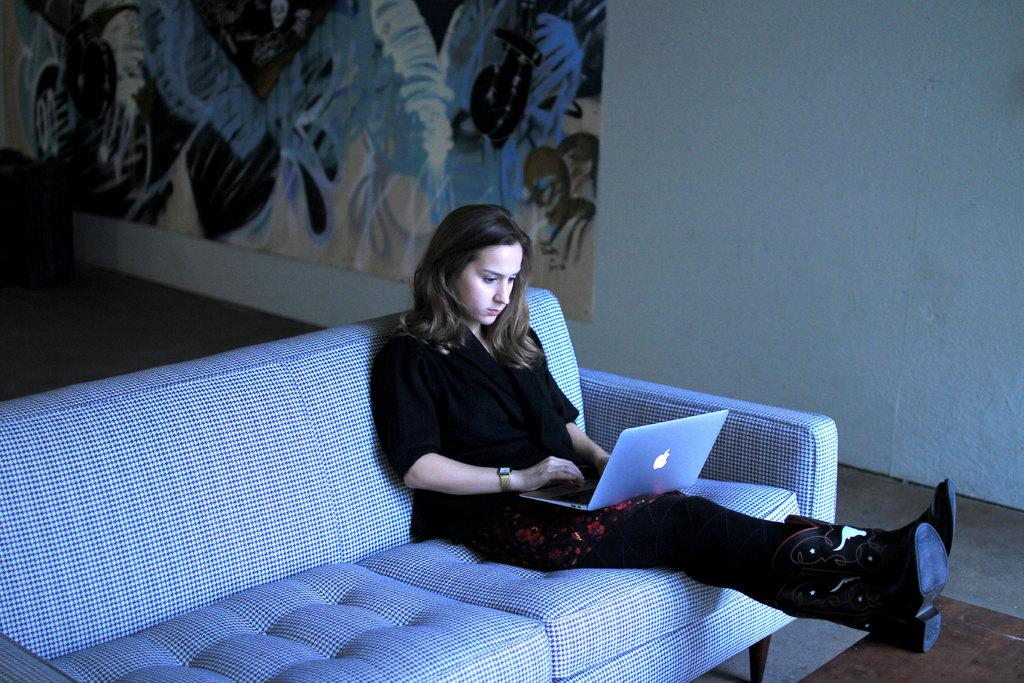Who is the main subject in the image? There is a girl in the image. What is the girl doing in the image? The girl is sitting on a sofa. What object is the girl holding in the image? The girl is holding a laptop. What can be seen on the wall behind the girl? There is a big painting on the wall behind her. What type of train is passing by in the image? There is no train present in the image; it features a girl sitting on a sofa with a laptop and a big painting on the wall behind her. What is the girl's partner doing in the image? There is no partner present in the image; it only shows the girl sitting on a sofa with a laptop. 